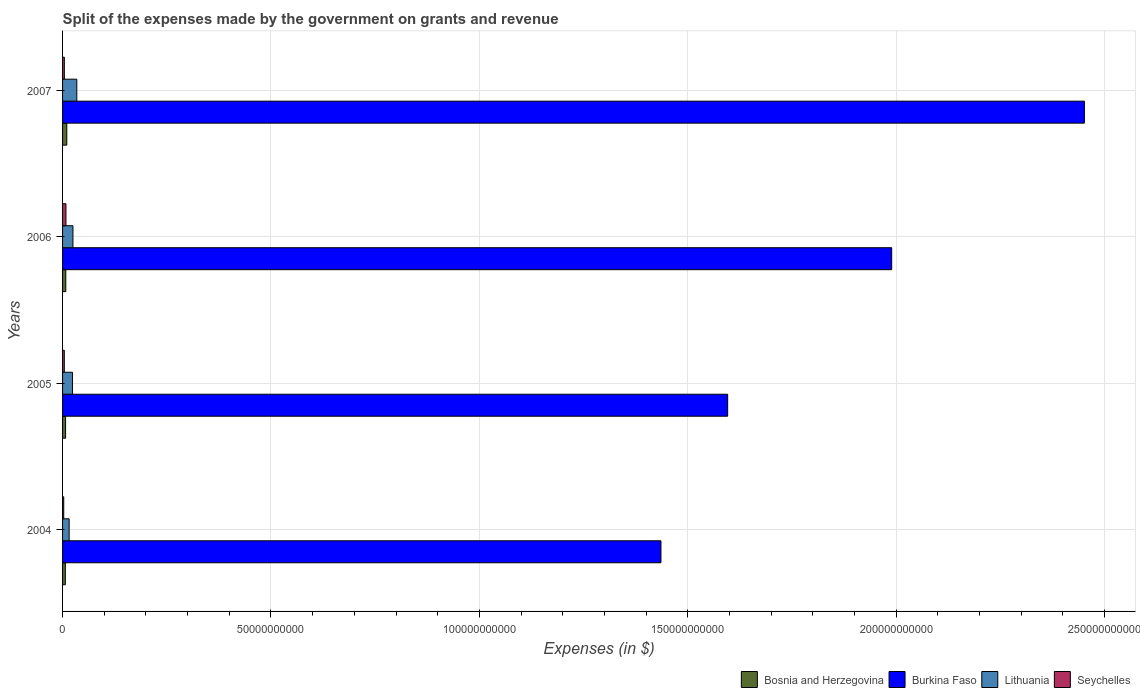Are the number of bars per tick equal to the number of legend labels?
Keep it short and to the point. Yes. Are the number of bars on each tick of the Y-axis equal?
Your answer should be compact. Yes. How many bars are there on the 3rd tick from the top?
Keep it short and to the point. 4. How many bars are there on the 4th tick from the bottom?
Give a very brief answer. 4. What is the label of the 1st group of bars from the top?
Keep it short and to the point. 2007. What is the expenses made by the government on grants and revenue in Bosnia and Herzegovina in 2007?
Give a very brief answer. 1.02e+09. Across all years, what is the maximum expenses made by the government on grants and revenue in Lithuania?
Your response must be concise. 3.42e+09. Across all years, what is the minimum expenses made by the government on grants and revenue in Burkina Faso?
Give a very brief answer. 1.44e+11. In which year was the expenses made by the government on grants and revenue in Seychelles minimum?
Keep it short and to the point. 2004. What is the total expenses made by the government on grants and revenue in Burkina Faso in the graph?
Make the answer very short. 7.47e+11. What is the difference between the expenses made by the government on grants and revenue in Seychelles in 2005 and that in 2007?
Your answer should be compact. -7.91e+06. What is the difference between the expenses made by the government on grants and revenue in Burkina Faso in 2004 and the expenses made by the government on grants and revenue in Lithuania in 2006?
Offer a terse response. 1.41e+11. What is the average expenses made by the government on grants and revenue in Bosnia and Herzegovina per year?
Ensure brevity in your answer.  7.93e+08. In the year 2006, what is the difference between the expenses made by the government on grants and revenue in Seychelles and expenses made by the government on grants and revenue in Burkina Faso?
Provide a succinct answer. -1.98e+11. What is the ratio of the expenses made by the government on grants and revenue in Burkina Faso in 2004 to that in 2005?
Give a very brief answer. 0.9. Is the expenses made by the government on grants and revenue in Bosnia and Herzegovina in 2005 less than that in 2007?
Offer a terse response. Yes. Is the difference between the expenses made by the government on grants and revenue in Seychelles in 2004 and 2006 greater than the difference between the expenses made by the government on grants and revenue in Burkina Faso in 2004 and 2006?
Offer a terse response. Yes. What is the difference between the highest and the second highest expenses made by the government on grants and revenue in Bosnia and Herzegovina?
Your answer should be compact. 2.43e+08. What is the difference between the highest and the lowest expenses made by the government on grants and revenue in Burkina Faso?
Make the answer very short. 1.02e+11. Is the sum of the expenses made by the government on grants and revenue in Burkina Faso in 2005 and 2006 greater than the maximum expenses made by the government on grants and revenue in Lithuania across all years?
Provide a succinct answer. Yes. Is it the case that in every year, the sum of the expenses made by the government on grants and revenue in Lithuania and expenses made by the government on grants and revenue in Seychelles is greater than the sum of expenses made by the government on grants and revenue in Burkina Faso and expenses made by the government on grants and revenue in Bosnia and Herzegovina?
Your response must be concise. No. What does the 2nd bar from the top in 2004 represents?
Keep it short and to the point. Lithuania. What does the 4th bar from the bottom in 2007 represents?
Offer a very short reply. Seychelles. Is it the case that in every year, the sum of the expenses made by the government on grants and revenue in Burkina Faso and expenses made by the government on grants and revenue in Lithuania is greater than the expenses made by the government on grants and revenue in Seychelles?
Provide a short and direct response. Yes. How many bars are there?
Your response must be concise. 16. Are all the bars in the graph horizontal?
Ensure brevity in your answer.  Yes. What is the difference between two consecutive major ticks on the X-axis?
Your answer should be very brief. 5.00e+1. Are the values on the major ticks of X-axis written in scientific E-notation?
Provide a short and direct response. No. Does the graph contain any zero values?
Provide a succinct answer. No. What is the title of the graph?
Your answer should be very brief. Split of the expenses made by the government on grants and revenue. What is the label or title of the X-axis?
Ensure brevity in your answer.  Expenses (in $). What is the Expenses (in $) of Bosnia and Herzegovina in 2004?
Offer a very short reply. 6.61e+08. What is the Expenses (in $) of Burkina Faso in 2004?
Keep it short and to the point. 1.44e+11. What is the Expenses (in $) of Lithuania in 2004?
Your response must be concise. 1.58e+09. What is the Expenses (in $) in Seychelles in 2004?
Your answer should be very brief. 2.82e+08. What is the Expenses (in $) of Bosnia and Herzegovina in 2005?
Provide a short and direct response. 7.22e+08. What is the Expenses (in $) in Burkina Faso in 2005?
Give a very brief answer. 1.60e+11. What is the Expenses (in $) of Lithuania in 2005?
Keep it short and to the point. 2.38e+09. What is the Expenses (in $) of Seychelles in 2005?
Your answer should be compact. 4.19e+08. What is the Expenses (in $) of Bosnia and Herzegovina in 2006?
Your answer should be compact. 7.73e+08. What is the Expenses (in $) in Burkina Faso in 2006?
Keep it short and to the point. 1.99e+11. What is the Expenses (in $) of Lithuania in 2006?
Ensure brevity in your answer.  2.49e+09. What is the Expenses (in $) of Seychelles in 2006?
Your answer should be very brief. 8.11e+08. What is the Expenses (in $) of Bosnia and Herzegovina in 2007?
Provide a succinct answer. 1.02e+09. What is the Expenses (in $) of Burkina Faso in 2007?
Offer a very short reply. 2.45e+11. What is the Expenses (in $) in Lithuania in 2007?
Your answer should be compact. 3.42e+09. What is the Expenses (in $) of Seychelles in 2007?
Your answer should be very brief. 4.27e+08. Across all years, what is the maximum Expenses (in $) of Bosnia and Herzegovina?
Offer a terse response. 1.02e+09. Across all years, what is the maximum Expenses (in $) of Burkina Faso?
Provide a succinct answer. 2.45e+11. Across all years, what is the maximum Expenses (in $) in Lithuania?
Your answer should be very brief. 3.42e+09. Across all years, what is the maximum Expenses (in $) of Seychelles?
Offer a terse response. 8.11e+08. Across all years, what is the minimum Expenses (in $) of Bosnia and Herzegovina?
Offer a terse response. 6.61e+08. Across all years, what is the minimum Expenses (in $) in Burkina Faso?
Your answer should be compact. 1.44e+11. Across all years, what is the minimum Expenses (in $) in Lithuania?
Make the answer very short. 1.58e+09. Across all years, what is the minimum Expenses (in $) in Seychelles?
Your response must be concise. 2.82e+08. What is the total Expenses (in $) in Bosnia and Herzegovina in the graph?
Your response must be concise. 3.17e+09. What is the total Expenses (in $) of Burkina Faso in the graph?
Give a very brief answer. 7.47e+11. What is the total Expenses (in $) of Lithuania in the graph?
Your answer should be compact. 9.87e+09. What is the total Expenses (in $) of Seychelles in the graph?
Make the answer very short. 1.94e+09. What is the difference between the Expenses (in $) of Bosnia and Herzegovina in 2004 and that in 2005?
Your response must be concise. -6.09e+07. What is the difference between the Expenses (in $) of Burkina Faso in 2004 and that in 2005?
Your answer should be very brief. -1.60e+1. What is the difference between the Expenses (in $) in Lithuania in 2004 and that in 2005?
Your response must be concise. -7.95e+08. What is the difference between the Expenses (in $) in Seychelles in 2004 and that in 2005?
Your answer should be very brief. -1.37e+08. What is the difference between the Expenses (in $) of Bosnia and Herzegovina in 2004 and that in 2006?
Offer a terse response. -1.12e+08. What is the difference between the Expenses (in $) in Burkina Faso in 2004 and that in 2006?
Your answer should be very brief. -5.54e+1. What is the difference between the Expenses (in $) in Lithuania in 2004 and that in 2006?
Your answer should be very brief. -9.10e+08. What is the difference between the Expenses (in $) of Seychelles in 2004 and that in 2006?
Your answer should be very brief. -5.29e+08. What is the difference between the Expenses (in $) of Bosnia and Herzegovina in 2004 and that in 2007?
Ensure brevity in your answer.  -3.55e+08. What is the difference between the Expenses (in $) of Burkina Faso in 2004 and that in 2007?
Provide a succinct answer. -1.02e+11. What is the difference between the Expenses (in $) in Lithuania in 2004 and that in 2007?
Offer a terse response. -1.84e+09. What is the difference between the Expenses (in $) in Seychelles in 2004 and that in 2007?
Your answer should be compact. -1.45e+08. What is the difference between the Expenses (in $) in Bosnia and Herzegovina in 2005 and that in 2006?
Provide a short and direct response. -5.11e+07. What is the difference between the Expenses (in $) in Burkina Faso in 2005 and that in 2006?
Offer a very short reply. -3.94e+1. What is the difference between the Expenses (in $) of Lithuania in 2005 and that in 2006?
Your response must be concise. -1.15e+08. What is the difference between the Expenses (in $) of Seychelles in 2005 and that in 2006?
Your answer should be very brief. -3.92e+08. What is the difference between the Expenses (in $) of Bosnia and Herzegovina in 2005 and that in 2007?
Give a very brief answer. -2.94e+08. What is the difference between the Expenses (in $) of Burkina Faso in 2005 and that in 2007?
Offer a very short reply. -8.56e+1. What is the difference between the Expenses (in $) in Lithuania in 2005 and that in 2007?
Ensure brevity in your answer.  -1.04e+09. What is the difference between the Expenses (in $) of Seychelles in 2005 and that in 2007?
Ensure brevity in your answer.  -7.91e+06. What is the difference between the Expenses (in $) of Bosnia and Herzegovina in 2006 and that in 2007?
Your response must be concise. -2.43e+08. What is the difference between the Expenses (in $) in Burkina Faso in 2006 and that in 2007?
Provide a short and direct response. -4.62e+1. What is the difference between the Expenses (in $) in Lithuania in 2006 and that in 2007?
Your response must be concise. -9.29e+08. What is the difference between the Expenses (in $) of Seychelles in 2006 and that in 2007?
Ensure brevity in your answer.  3.84e+08. What is the difference between the Expenses (in $) in Bosnia and Herzegovina in 2004 and the Expenses (in $) in Burkina Faso in 2005?
Ensure brevity in your answer.  -1.59e+11. What is the difference between the Expenses (in $) in Bosnia and Herzegovina in 2004 and the Expenses (in $) in Lithuania in 2005?
Your answer should be compact. -1.71e+09. What is the difference between the Expenses (in $) in Bosnia and Herzegovina in 2004 and the Expenses (in $) in Seychelles in 2005?
Ensure brevity in your answer.  2.43e+08. What is the difference between the Expenses (in $) of Burkina Faso in 2004 and the Expenses (in $) of Lithuania in 2005?
Your answer should be compact. 1.41e+11. What is the difference between the Expenses (in $) in Burkina Faso in 2004 and the Expenses (in $) in Seychelles in 2005?
Your answer should be very brief. 1.43e+11. What is the difference between the Expenses (in $) in Lithuania in 2004 and the Expenses (in $) in Seychelles in 2005?
Your answer should be very brief. 1.16e+09. What is the difference between the Expenses (in $) of Bosnia and Herzegovina in 2004 and the Expenses (in $) of Burkina Faso in 2006?
Offer a terse response. -1.98e+11. What is the difference between the Expenses (in $) in Bosnia and Herzegovina in 2004 and the Expenses (in $) in Lithuania in 2006?
Your answer should be compact. -1.83e+09. What is the difference between the Expenses (in $) of Bosnia and Herzegovina in 2004 and the Expenses (in $) of Seychelles in 2006?
Provide a short and direct response. -1.50e+08. What is the difference between the Expenses (in $) of Burkina Faso in 2004 and the Expenses (in $) of Lithuania in 2006?
Give a very brief answer. 1.41e+11. What is the difference between the Expenses (in $) of Burkina Faso in 2004 and the Expenses (in $) of Seychelles in 2006?
Your response must be concise. 1.43e+11. What is the difference between the Expenses (in $) of Lithuania in 2004 and the Expenses (in $) of Seychelles in 2006?
Your response must be concise. 7.70e+08. What is the difference between the Expenses (in $) of Bosnia and Herzegovina in 2004 and the Expenses (in $) of Burkina Faso in 2007?
Make the answer very short. -2.44e+11. What is the difference between the Expenses (in $) of Bosnia and Herzegovina in 2004 and the Expenses (in $) of Lithuania in 2007?
Your answer should be compact. -2.76e+09. What is the difference between the Expenses (in $) of Bosnia and Herzegovina in 2004 and the Expenses (in $) of Seychelles in 2007?
Provide a short and direct response. 2.35e+08. What is the difference between the Expenses (in $) in Burkina Faso in 2004 and the Expenses (in $) in Lithuania in 2007?
Keep it short and to the point. 1.40e+11. What is the difference between the Expenses (in $) in Burkina Faso in 2004 and the Expenses (in $) in Seychelles in 2007?
Make the answer very short. 1.43e+11. What is the difference between the Expenses (in $) of Lithuania in 2004 and the Expenses (in $) of Seychelles in 2007?
Your response must be concise. 1.15e+09. What is the difference between the Expenses (in $) of Bosnia and Herzegovina in 2005 and the Expenses (in $) of Burkina Faso in 2006?
Offer a very short reply. -1.98e+11. What is the difference between the Expenses (in $) of Bosnia and Herzegovina in 2005 and the Expenses (in $) of Lithuania in 2006?
Keep it short and to the point. -1.77e+09. What is the difference between the Expenses (in $) of Bosnia and Herzegovina in 2005 and the Expenses (in $) of Seychelles in 2006?
Your answer should be compact. -8.86e+07. What is the difference between the Expenses (in $) in Burkina Faso in 2005 and the Expenses (in $) in Lithuania in 2006?
Your answer should be compact. 1.57e+11. What is the difference between the Expenses (in $) of Burkina Faso in 2005 and the Expenses (in $) of Seychelles in 2006?
Offer a terse response. 1.59e+11. What is the difference between the Expenses (in $) in Lithuania in 2005 and the Expenses (in $) in Seychelles in 2006?
Ensure brevity in your answer.  1.57e+09. What is the difference between the Expenses (in $) of Bosnia and Herzegovina in 2005 and the Expenses (in $) of Burkina Faso in 2007?
Keep it short and to the point. -2.44e+11. What is the difference between the Expenses (in $) of Bosnia and Herzegovina in 2005 and the Expenses (in $) of Lithuania in 2007?
Keep it short and to the point. -2.70e+09. What is the difference between the Expenses (in $) of Bosnia and Herzegovina in 2005 and the Expenses (in $) of Seychelles in 2007?
Offer a very short reply. 2.96e+08. What is the difference between the Expenses (in $) in Burkina Faso in 2005 and the Expenses (in $) in Lithuania in 2007?
Your answer should be very brief. 1.56e+11. What is the difference between the Expenses (in $) in Burkina Faso in 2005 and the Expenses (in $) in Seychelles in 2007?
Provide a succinct answer. 1.59e+11. What is the difference between the Expenses (in $) of Lithuania in 2005 and the Expenses (in $) of Seychelles in 2007?
Give a very brief answer. 1.95e+09. What is the difference between the Expenses (in $) in Bosnia and Herzegovina in 2006 and the Expenses (in $) in Burkina Faso in 2007?
Your answer should be very brief. -2.44e+11. What is the difference between the Expenses (in $) in Bosnia and Herzegovina in 2006 and the Expenses (in $) in Lithuania in 2007?
Make the answer very short. -2.65e+09. What is the difference between the Expenses (in $) in Bosnia and Herzegovina in 2006 and the Expenses (in $) in Seychelles in 2007?
Give a very brief answer. 3.47e+08. What is the difference between the Expenses (in $) in Burkina Faso in 2006 and the Expenses (in $) in Lithuania in 2007?
Offer a very short reply. 1.96e+11. What is the difference between the Expenses (in $) in Burkina Faso in 2006 and the Expenses (in $) in Seychelles in 2007?
Your answer should be compact. 1.98e+11. What is the difference between the Expenses (in $) of Lithuania in 2006 and the Expenses (in $) of Seychelles in 2007?
Keep it short and to the point. 2.06e+09. What is the average Expenses (in $) in Bosnia and Herzegovina per year?
Make the answer very short. 7.93e+08. What is the average Expenses (in $) in Burkina Faso per year?
Your answer should be compact. 1.87e+11. What is the average Expenses (in $) of Lithuania per year?
Offer a very short reply. 2.47e+09. What is the average Expenses (in $) in Seychelles per year?
Offer a terse response. 4.84e+08. In the year 2004, what is the difference between the Expenses (in $) of Bosnia and Herzegovina and Expenses (in $) of Burkina Faso?
Give a very brief answer. -1.43e+11. In the year 2004, what is the difference between the Expenses (in $) in Bosnia and Herzegovina and Expenses (in $) in Lithuania?
Offer a very short reply. -9.20e+08. In the year 2004, what is the difference between the Expenses (in $) of Bosnia and Herzegovina and Expenses (in $) of Seychelles?
Offer a terse response. 3.80e+08. In the year 2004, what is the difference between the Expenses (in $) of Burkina Faso and Expenses (in $) of Lithuania?
Offer a very short reply. 1.42e+11. In the year 2004, what is the difference between the Expenses (in $) in Burkina Faso and Expenses (in $) in Seychelles?
Make the answer very short. 1.43e+11. In the year 2004, what is the difference between the Expenses (in $) in Lithuania and Expenses (in $) in Seychelles?
Your answer should be compact. 1.30e+09. In the year 2005, what is the difference between the Expenses (in $) in Bosnia and Herzegovina and Expenses (in $) in Burkina Faso?
Make the answer very short. -1.59e+11. In the year 2005, what is the difference between the Expenses (in $) of Bosnia and Herzegovina and Expenses (in $) of Lithuania?
Your response must be concise. -1.65e+09. In the year 2005, what is the difference between the Expenses (in $) of Bosnia and Herzegovina and Expenses (in $) of Seychelles?
Your answer should be compact. 3.04e+08. In the year 2005, what is the difference between the Expenses (in $) in Burkina Faso and Expenses (in $) in Lithuania?
Offer a terse response. 1.57e+11. In the year 2005, what is the difference between the Expenses (in $) in Burkina Faso and Expenses (in $) in Seychelles?
Provide a short and direct response. 1.59e+11. In the year 2005, what is the difference between the Expenses (in $) of Lithuania and Expenses (in $) of Seychelles?
Provide a short and direct response. 1.96e+09. In the year 2006, what is the difference between the Expenses (in $) of Bosnia and Herzegovina and Expenses (in $) of Burkina Faso?
Your response must be concise. -1.98e+11. In the year 2006, what is the difference between the Expenses (in $) in Bosnia and Herzegovina and Expenses (in $) in Lithuania?
Ensure brevity in your answer.  -1.72e+09. In the year 2006, what is the difference between the Expenses (in $) of Bosnia and Herzegovina and Expenses (in $) of Seychelles?
Ensure brevity in your answer.  -3.76e+07. In the year 2006, what is the difference between the Expenses (in $) in Burkina Faso and Expenses (in $) in Lithuania?
Your answer should be very brief. 1.96e+11. In the year 2006, what is the difference between the Expenses (in $) of Burkina Faso and Expenses (in $) of Seychelles?
Provide a succinct answer. 1.98e+11. In the year 2006, what is the difference between the Expenses (in $) in Lithuania and Expenses (in $) in Seychelles?
Ensure brevity in your answer.  1.68e+09. In the year 2007, what is the difference between the Expenses (in $) of Bosnia and Herzegovina and Expenses (in $) of Burkina Faso?
Make the answer very short. -2.44e+11. In the year 2007, what is the difference between the Expenses (in $) of Bosnia and Herzegovina and Expenses (in $) of Lithuania?
Offer a very short reply. -2.40e+09. In the year 2007, what is the difference between the Expenses (in $) of Bosnia and Herzegovina and Expenses (in $) of Seychelles?
Your response must be concise. 5.90e+08. In the year 2007, what is the difference between the Expenses (in $) of Burkina Faso and Expenses (in $) of Lithuania?
Provide a succinct answer. 2.42e+11. In the year 2007, what is the difference between the Expenses (in $) in Burkina Faso and Expenses (in $) in Seychelles?
Make the answer very short. 2.45e+11. In the year 2007, what is the difference between the Expenses (in $) in Lithuania and Expenses (in $) in Seychelles?
Your answer should be very brief. 2.99e+09. What is the ratio of the Expenses (in $) of Bosnia and Herzegovina in 2004 to that in 2005?
Make the answer very short. 0.92. What is the ratio of the Expenses (in $) of Burkina Faso in 2004 to that in 2005?
Your answer should be compact. 0.9. What is the ratio of the Expenses (in $) of Lithuania in 2004 to that in 2005?
Your response must be concise. 0.67. What is the ratio of the Expenses (in $) in Seychelles in 2004 to that in 2005?
Offer a very short reply. 0.67. What is the ratio of the Expenses (in $) of Bosnia and Herzegovina in 2004 to that in 2006?
Give a very brief answer. 0.86. What is the ratio of the Expenses (in $) in Burkina Faso in 2004 to that in 2006?
Your answer should be very brief. 0.72. What is the ratio of the Expenses (in $) of Lithuania in 2004 to that in 2006?
Give a very brief answer. 0.63. What is the ratio of the Expenses (in $) of Seychelles in 2004 to that in 2006?
Your answer should be very brief. 0.35. What is the ratio of the Expenses (in $) in Bosnia and Herzegovina in 2004 to that in 2007?
Provide a succinct answer. 0.65. What is the ratio of the Expenses (in $) in Burkina Faso in 2004 to that in 2007?
Your response must be concise. 0.59. What is the ratio of the Expenses (in $) of Lithuania in 2004 to that in 2007?
Offer a terse response. 0.46. What is the ratio of the Expenses (in $) in Seychelles in 2004 to that in 2007?
Keep it short and to the point. 0.66. What is the ratio of the Expenses (in $) of Bosnia and Herzegovina in 2005 to that in 2006?
Your response must be concise. 0.93. What is the ratio of the Expenses (in $) of Burkina Faso in 2005 to that in 2006?
Your answer should be very brief. 0.8. What is the ratio of the Expenses (in $) of Lithuania in 2005 to that in 2006?
Provide a short and direct response. 0.95. What is the ratio of the Expenses (in $) in Seychelles in 2005 to that in 2006?
Your answer should be compact. 0.52. What is the ratio of the Expenses (in $) in Bosnia and Herzegovina in 2005 to that in 2007?
Provide a short and direct response. 0.71. What is the ratio of the Expenses (in $) in Burkina Faso in 2005 to that in 2007?
Offer a terse response. 0.65. What is the ratio of the Expenses (in $) of Lithuania in 2005 to that in 2007?
Offer a terse response. 0.69. What is the ratio of the Expenses (in $) of Seychelles in 2005 to that in 2007?
Provide a short and direct response. 0.98. What is the ratio of the Expenses (in $) of Bosnia and Herzegovina in 2006 to that in 2007?
Give a very brief answer. 0.76. What is the ratio of the Expenses (in $) of Burkina Faso in 2006 to that in 2007?
Provide a short and direct response. 0.81. What is the ratio of the Expenses (in $) in Lithuania in 2006 to that in 2007?
Offer a very short reply. 0.73. What is the ratio of the Expenses (in $) in Seychelles in 2006 to that in 2007?
Ensure brevity in your answer.  1.9. What is the difference between the highest and the second highest Expenses (in $) of Bosnia and Herzegovina?
Offer a very short reply. 2.43e+08. What is the difference between the highest and the second highest Expenses (in $) in Burkina Faso?
Provide a short and direct response. 4.62e+1. What is the difference between the highest and the second highest Expenses (in $) in Lithuania?
Provide a short and direct response. 9.29e+08. What is the difference between the highest and the second highest Expenses (in $) in Seychelles?
Your answer should be compact. 3.84e+08. What is the difference between the highest and the lowest Expenses (in $) of Bosnia and Herzegovina?
Your answer should be very brief. 3.55e+08. What is the difference between the highest and the lowest Expenses (in $) in Burkina Faso?
Offer a terse response. 1.02e+11. What is the difference between the highest and the lowest Expenses (in $) in Lithuania?
Give a very brief answer. 1.84e+09. What is the difference between the highest and the lowest Expenses (in $) of Seychelles?
Your response must be concise. 5.29e+08. 